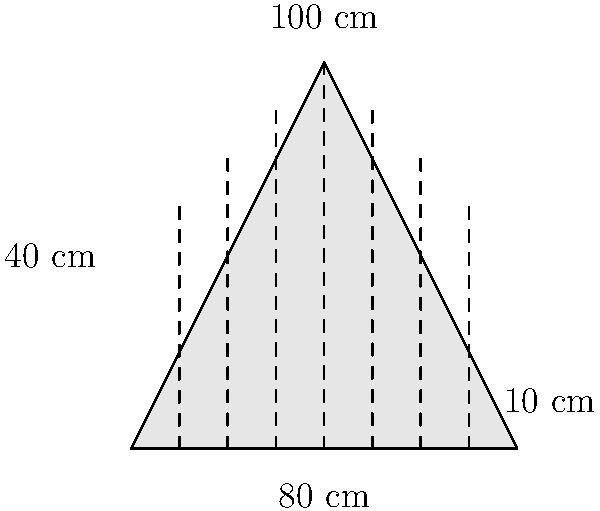A hanbok skirt is shaped like an isosceles trapezoid with a base of 80 cm, a top of 100 cm, and a height of 40 cm. The skirt has 7 equally spaced pleats, each with a depth of 10 cm. Calculate the total surface area of fabric needed to create this pleated skirt. To calculate the total surface area of fabric needed, we'll follow these steps:

1. Calculate the area of the trapezoid (main skirt area):
   $$A_{trapezoid} = \frac{1}{2}(b_1 + b_2)h$$
   $$A_{trapezoid} = \frac{1}{2}(80 + 100) \times 40 = 3600 \text{ cm}^2$$

2. Calculate the additional fabric needed for pleats:
   - Each pleat requires twice its depth in extra fabric
   - There are 7 pleats, each 10 cm deep
   - Extra fabric per pleat = $2 \times 10 = 20 \text{ cm}$
   - Total extra fabric width = $7 \times 20 = 140 \text{ cm}$

3. Calculate the area of the extra fabric for pleats:
   $$A_{pleats} = 140 \times 40 = 5600 \text{ cm}^2$$

4. Sum up the total area:
   $$A_{total} = A_{trapezoid} + A_{pleats}$$
   $$A_{total} = 3600 + 5600 = 9200 \text{ cm}^2$$

Therefore, the total surface area of fabric needed is 9200 cm².
Answer: 9200 cm² 